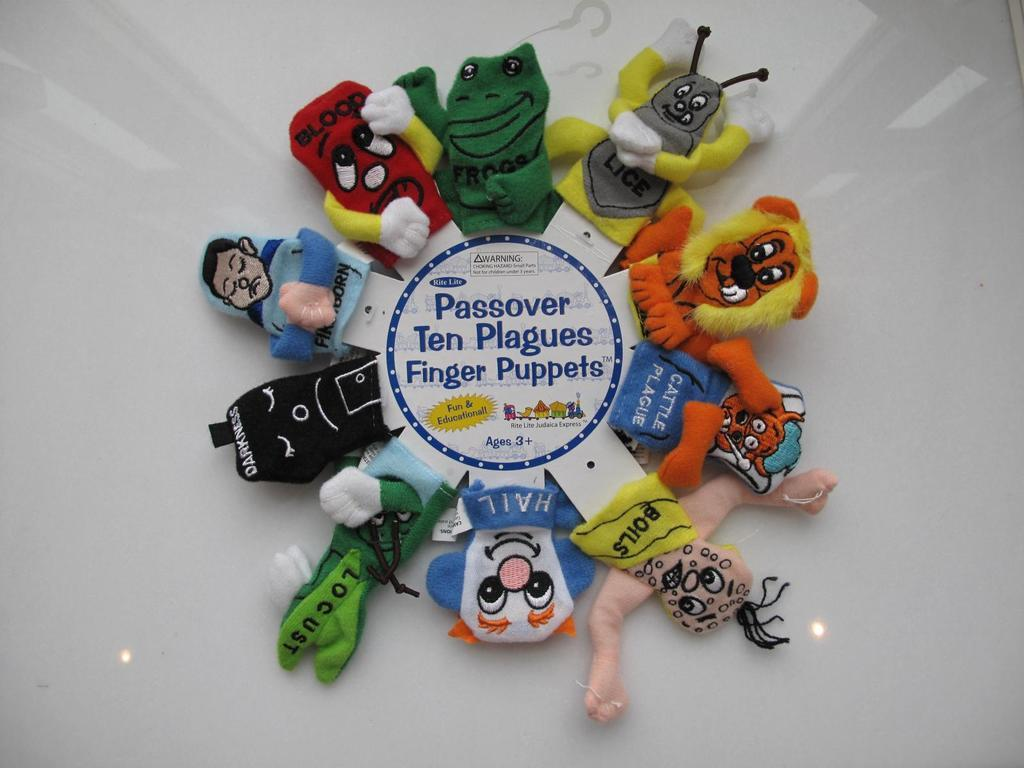What type of toys are featured in the image? There are finger puppets in the image. What else can be seen in the image besides the finger puppets? There is text in the image. Can you describe the setting in which the finger puppets are located? There appears to be a table in the background of the image. What type of window can be seen in the image? There is no window present in the image. How many hooks are visible in the image? There are no hooks visible in the image. 